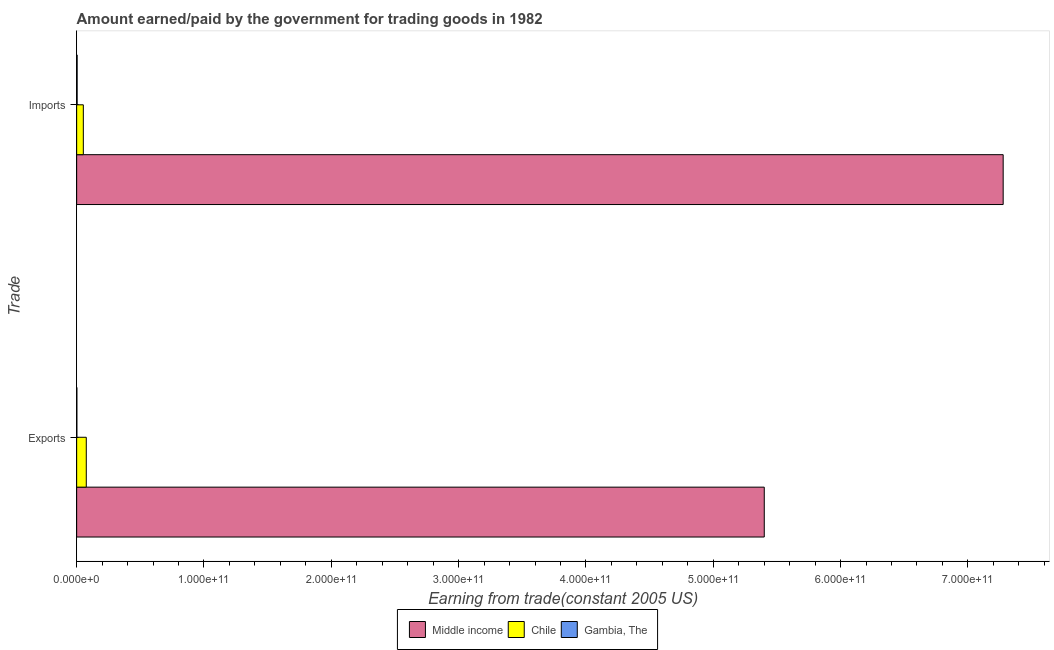What is the label of the 1st group of bars from the top?
Offer a very short reply. Imports. What is the amount paid for imports in Chile?
Your answer should be compact. 5.24e+09. Across all countries, what is the maximum amount earned from exports?
Make the answer very short. 5.40e+11. Across all countries, what is the minimum amount earned from exports?
Make the answer very short. 1.74e+08. In which country was the amount paid for imports maximum?
Your response must be concise. Middle income. In which country was the amount earned from exports minimum?
Keep it short and to the point. Gambia, The. What is the total amount paid for imports in the graph?
Keep it short and to the point. 7.33e+11. What is the difference between the amount paid for imports in Chile and that in Gambia, The?
Make the answer very short. 4.87e+09. What is the difference between the amount paid for imports in Chile and the amount earned from exports in Gambia, The?
Provide a succinct answer. 5.07e+09. What is the average amount paid for imports per country?
Give a very brief answer. 2.44e+11. What is the difference between the amount earned from exports and amount paid for imports in Middle income?
Offer a terse response. -1.88e+11. What is the ratio of the amount paid for imports in Gambia, The to that in Chile?
Give a very brief answer. 0.07. Is the amount earned from exports in Chile less than that in Middle income?
Make the answer very short. Yes. In how many countries, is the amount earned from exports greater than the average amount earned from exports taken over all countries?
Your answer should be very brief. 1. What does the 1st bar from the top in Imports represents?
Keep it short and to the point. Gambia, The. What does the 1st bar from the bottom in Exports represents?
Give a very brief answer. Middle income. How many bars are there?
Offer a terse response. 6. How many countries are there in the graph?
Keep it short and to the point. 3. What is the difference between two consecutive major ticks on the X-axis?
Provide a short and direct response. 1.00e+11. Where does the legend appear in the graph?
Offer a terse response. Bottom center. How many legend labels are there?
Your answer should be compact. 3. How are the legend labels stacked?
Provide a short and direct response. Horizontal. What is the title of the graph?
Make the answer very short. Amount earned/paid by the government for trading goods in 1982. What is the label or title of the X-axis?
Your response must be concise. Earning from trade(constant 2005 US). What is the label or title of the Y-axis?
Make the answer very short. Trade. What is the Earning from trade(constant 2005 US) in Middle income in Exports?
Your answer should be compact. 5.40e+11. What is the Earning from trade(constant 2005 US) in Chile in Exports?
Offer a terse response. 7.56e+09. What is the Earning from trade(constant 2005 US) in Gambia, The in Exports?
Provide a succinct answer. 1.74e+08. What is the Earning from trade(constant 2005 US) in Middle income in Imports?
Offer a very short reply. 7.28e+11. What is the Earning from trade(constant 2005 US) of Chile in Imports?
Make the answer very short. 5.24e+09. What is the Earning from trade(constant 2005 US) in Gambia, The in Imports?
Offer a terse response. 3.78e+08. Across all Trade, what is the maximum Earning from trade(constant 2005 US) of Middle income?
Provide a short and direct response. 7.28e+11. Across all Trade, what is the maximum Earning from trade(constant 2005 US) of Chile?
Provide a succinct answer. 7.56e+09. Across all Trade, what is the maximum Earning from trade(constant 2005 US) in Gambia, The?
Give a very brief answer. 3.78e+08. Across all Trade, what is the minimum Earning from trade(constant 2005 US) of Middle income?
Give a very brief answer. 5.40e+11. Across all Trade, what is the minimum Earning from trade(constant 2005 US) of Chile?
Make the answer very short. 5.24e+09. Across all Trade, what is the minimum Earning from trade(constant 2005 US) of Gambia, The?
Offer a terse response. 1.74e+08. What is the total Earning from trade(constant 2005 US) of Middle income in the graph?
Your answer should be very brief. 1.27e+12. What is the total Earning from trade(constant 2005 US) in Chile in the graph?
Your response must be concise. 1.28e+1. What is the total Earning from trade(constant 2005 US) in Gambia, The in the graph?
Ensure brevity in your answer.  5.52e+08. What is the difference between the Earning from trade(constant 2005 US) of Middle income in Exports and that in Imports?
Offer a terse response. -1.88e+11. What is the difference between the Earning from trade(constant 2005 US) in Chile in Exports and that in Imports?
Your answer should be compact. 2.32e+09. What is the difference between the Earning from trade(constant 2005 US) in Gambia, The in Exports and that in Imports?
Your response must be concise. -2.04e+08. What is the difference between the Earning from trade(constant 2005 US) in Middle income in Exports and the Earning from trade(constant 2005 US) in Chile in Imports?
Your answer should be very brief. 5.35e+11. What is the difference between the Earning from trade(constant 2005 US) in Middle income in Exports and the Earning from trade(constant 2005 US) in Gambia, The in Imports?
Ensure brevity in your answer.  5.40e+11. What is the difference between the Earning from trade(constant 2005 US) in Chile in Exports and the Earning from trade(constant 2005 US) in Gambia, The in Imports?
Provide a succinct answer. 7.18e+09. What is the average Earning from trade(constant 2005 US) of Middle income per Trade?
Offer a terse response. 6.34e+11. What is the average Earning from trade(constant 2005 US) of Chile per Trade?
Provide a short and direct response. 6.40e+09. What is the average Earning from trade(constant 2005 US) in Gambia, The per Trade?
Offer a terse response. 2.76e+08. What is the difference between the Earning from trade(constant 2005 US) in Middle income and Earning from trade(constant 2005 US) in Chile in Exports?
Provide a succinct answer. 5.33e+11. What is the difference between the Earning from trade(constant 2005 US) in Middle income and Earning from trade(constant 2005 US) in Gambia, The in Exports?
Your answer should be very brief. 5.40e+11. What is the difference between the Earning from trade(constant 2005 US) in Chile and Earning from trade(constant 2005 US) in Gambia, The in Exports?
Keep it short and to the point. 7.39e+09. What is the difference between the Earning from trade(constant 2005 US) in Middle income and Earning from trade(constant 2005 US) in Chile in Imports?
Ensure brevity in your answer.  7.22e+11. What is the difference between the Earning from trade(constant 2005 US) of Middle income and Earning from trade(constant 2005 US) of Gambia, The in Imports?
Keep it short and to the point. 7.27e+11. What is the difference between the Earning from trade(constant 2005 US) in Chile and Earning from trade(constant 2005 US) in Gambia, The in Imports?
Keep it short and to the point. 4.87e+09. What is the ratio of the Earning from trade(constant 2005 US) of Middle income in Exports to that in Imports?
Your answer should be compact. 0.74. What is the ratio of the Earning from trade(constant 2005 US) of Chile in Exports to that in Imports?
Make the answer very short. 1.44. What is the ratio of the Earning from trade(constant 2005 US) of Gambia, The in Exports to that in Imports?
Offer a very short reply. 0.46. What is the difference between the highest and the second highest Earning from trade(constant 2005 US) in Middle income?
Provide a succinct answer. 1.88e+11. What is the difference between the highest and the second highest Earning from trade(constant 2005 US) of Chile?
Offer a terse response. 2.32e+09. What is the difference between the highest and the second highest Earning from trade(constant 2005 US) of Gambia, The?
Give a very brief answer. 2.04e+08. What is the difference between the highest and the lowest Earning from trade(constant 2005 US) in Middle income?
Keep it short and to the point. 1.88e+11. What is the difference between the highest and the lowest Earning from trade(constant 2005 US) of Chile?
Provide a short and direct response. 2.32e+09. What is the difference between the highest and the lowest Earning from trade(constant 2005 US) of Gambia, The?
Give a very brief answer. 2.04e+08. 